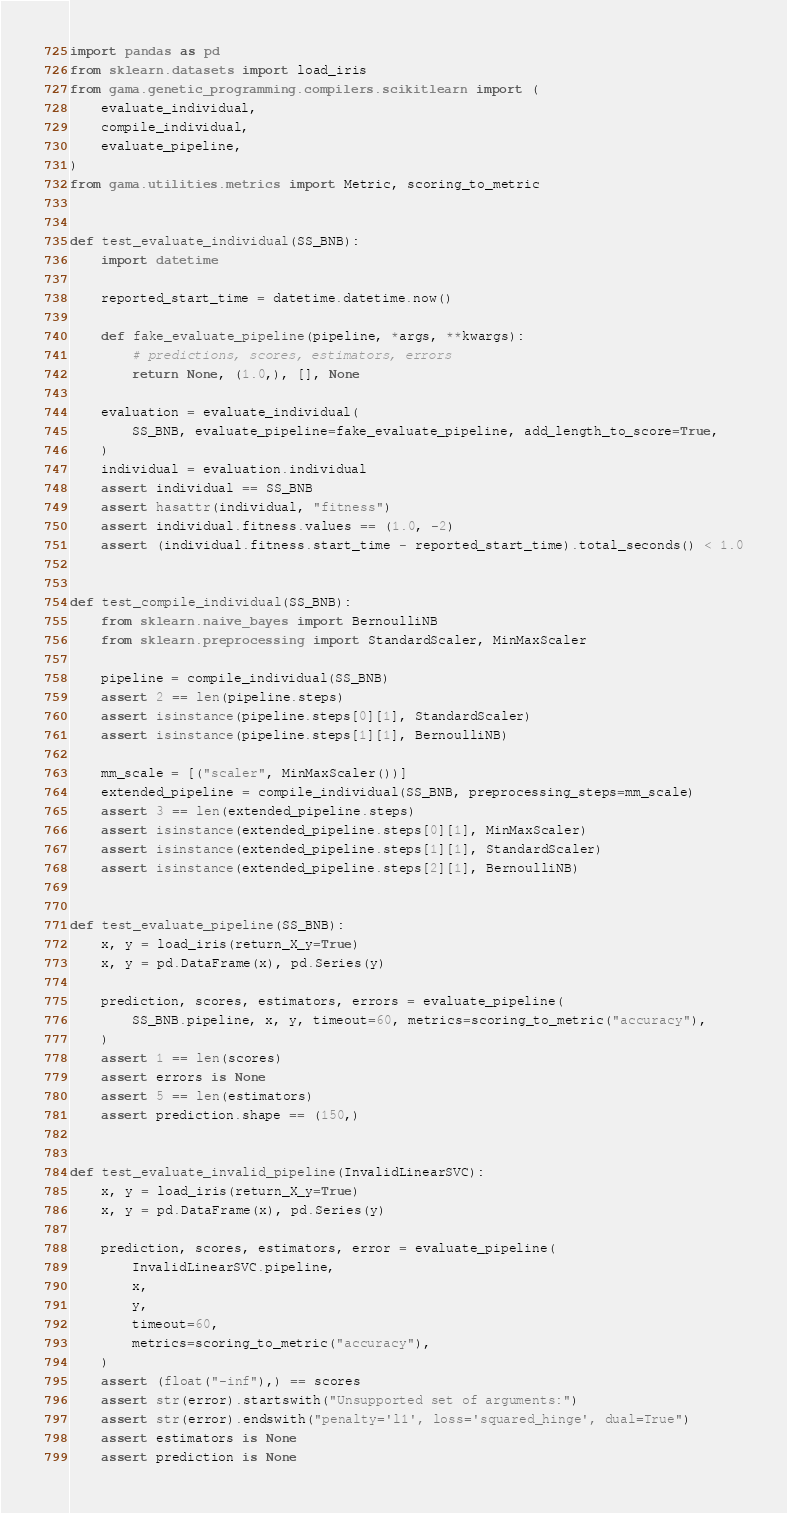Convert code to text. <code><loc_0><loc_0><loc_500><loc_500><_Python_>import pandas as pd
from sklearn.datasets import load_iris
from gama.genetic_programming.compilers.scikitlearn import (
    evaluate_individual,
    compile_individual,
    evaluate_pipeline,
)
from gama.utilities.metrics import Metric, scoring_to_metric


def test_evaluate_individual(SS_BNB):
    import datetime

    reported_start_time = datetime.datetime.now()

    def fake_evaluate_pipeline(pipeline, *args, **kwargs):
        # predictions, scores, estimators, errors
        return None, (1.0,), [], None

    evaluation = evaluate_individual(
        SS_BNB, evaluate_pipeline=fake_evaluate_pipeline, add_length_to_score=True,
    )
    individual = evaluation.individual
    assert individual == SS_BNB
    assert hasattr(individual, "fitness")
    assert individual.fitness.values == (1.0, -2)
    assert (individual.fitness.start_time - reported_start_time).total_seconds() < 1.0


def test_compile_individual(SS_BNB):
    from sklearn.naive_bayes import BernoulliNB
    from sklearn.preprocessing import StandardScaler, MinMaxScaler

    pipeline = compile_individual(SS_BNB)
    assert 2 == len(pipeline.steps)
    assert isinstance(pipeline.steps[0][1], StandardScaler)
    assert isinstance(pipeline.steps[1][1], BernoulliNB)

    mm_scale = [("scaler", MinMaxScaler())]
    extended_pipeline = compile_individual(SS_BNB, preprocessing_steps=mm_scale)
    assert 3 == len(extended_pipeline.steps)
    assert isinstance(extended_pipeline.steps[0][1], MinMaxScaler)
    assert isinstance(extended_pipeline.steps[1][1], StandardScaler)
    assert isinstance(extended_pipeline.steps[2][1], BernoulliNB)


def test_evaluate_pipeline(SS_BNB):
    x, y = load_iris(return_X_y=True)
    x, y = pd.DataFrame(x), pd.Series(y)

    prediction, scores, estimators, errors = evaluate_pipeline(
        SS_BNB.pipeline, x, y, timeout=60, metrics=scoring_to_metric("accuracy"),
    )
    assert 1 == len(scores)
    assert errors is None
    assert 5 == len(estimators)
    assert prediction.shape == (150,)


def test_evaluate_invalid_pipeline(InvalidLinearSVC):
    x, y = load_iris(return_X_y=True)
    x, y = pd.DataFrame(x), pd.Series(y)

    prediction, scores, estimators, error = evaluate_pipeline(
        InvalidLinearSVC.pipeline,
        x,
        y,
        timeout=60,
        metrics=scoring_to_metric("accuracy"),
    )
    assert (float("-inf"),) == scores
    assert str(error).startswith("Unsupported set of arguments:")
    assert str(error).endswith("penalty='l1', loss='squared_hinge', dual=True")
    assert estimators is None
    assert prediction is None
</code> 